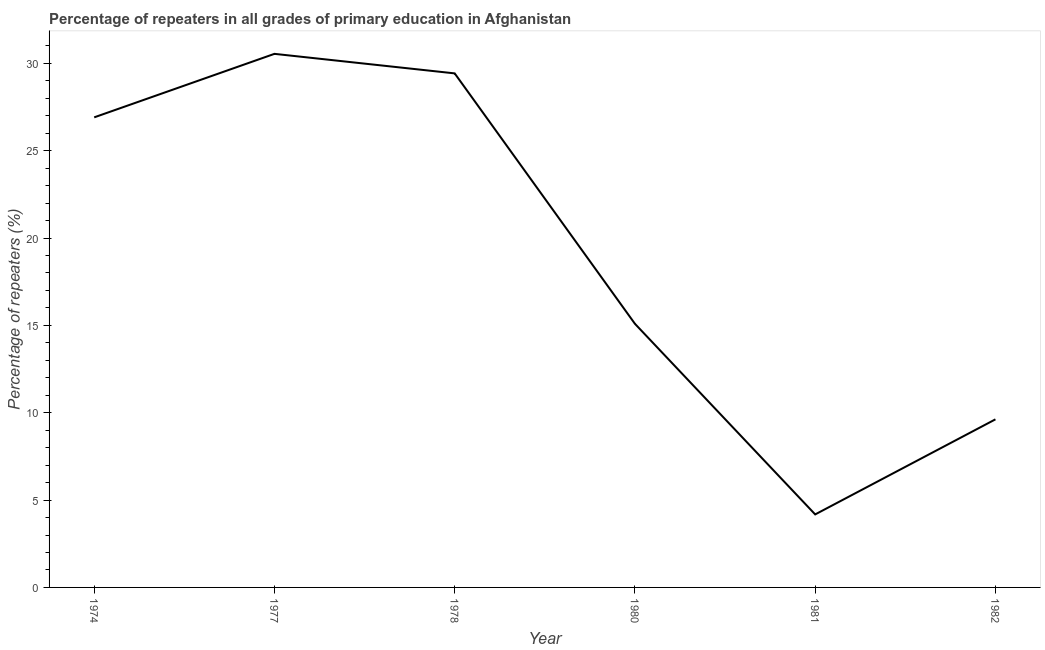What is the percentage of repeaters in primary education in 1978?
Keep it short and to the point. 29.43. Across all years, what is the maximum percentage of repeaters in primary education?
Provide a succinct answer. 30.54. Across all years, what is the minimum percentage of repeaters in primary education?
Your answer should be very brief. 4.18. In which year was the percentage of repeaters in primary education maximum?
Keep it short and to the point. 1977. What is the sum of the percentage of repeaters in primary education?
Your answer should be compact. 115.77. What is the difference between the percentage of repeaters in primary education in 1977 and 1978?
Give a very brief answer. 1.12. What is the average percentage of repeaters in primary education per year?
Provide a succinct answer. 19.3. What is the median percentage of repeaters in primary education?
Keep it short and to the point. 21. In how many years, is the percentage of repeaters in primary education greater than 8 %?
Offer a terse response. 5. Do a majority of the years between 1977 and 1980 (inclusive) have percentage of repeaters in primary education greater than 28 %?
Give a very brief answer. Yes. What is the ratio of the percentage of repeaters in primary education in 1981 to that in 1982?
Provide a succinct answer. 0.43. Is the percentage of repeaters in primary education in 1974 less than that in 1980?
Your response must be concise. No. Is the difference between the percentage of repeaters in primary education in 1978 and 1981 greater than the difference between any two years?
Make the answer very short. No. What is the difference between the highest and the second highest percentage of repeaters in primary education?
Give a very brief answer. 1.12. Is the sum of the percentage of repeaters in primary education in 1974 and 1978 greater than the maximum percentage of repeaters in primary education across all years?
Offer a terse response. Yes. What is the difference between the highest and the lowest percentage of repeaters in primary education?
Provide a succinct answer. 26.36. In how many years, is the percentage of repeaters in primary education greater than the average percentage of repeaters in primary education taken over all years?
Ensure brevity in your answer.  3. Does the percentage of repeaters in primary education monotonically increase over the years?
Keep it short and to the point. No. Are the values on the major ticks of Y-axis written in scientific E-notation?
Your answer should be very brief. No. Does the graph contain any zero values?
Make the answer very short. No. What is the title of the graph?
Your response must be concise. Percentage of repeaters in all grades of primary education in Afghanistan. What is the label or title of the Y-axis?
Offer a terse response. Percentage of repeaters (%). What is the Percentage of repeaters (%) in 1974?
Your answer should be very brief. 26.91. What is the Percentage of repeaters (%) in 1977?
Your answer should be very brief. 30.54. What is the Percentage of repeaters (%) in 1978?
Give a very brief answer. 29.43. What is the Percentage of repeaters (%) in 1980?
Provide a succinct answer. 15.09. What is the Percentage of repeaters (%) of 1981?
Give a very brief answer. 4.18. What is the Percentage of repeaters (%) in 1982?
Offer a terse response. 9.62. What is the difference between the Percentage of repeaters (%) in 1974 and 1977?
Offer a terse response. -3.64. What is the difference between the Percentage of repeaters (%) in 1974 and 1978?
Provide a succinct answer. -2.52. What is the difference between the Percentage of repeaters (%) in 1974 and 1980?
Make the answer very short. 11.82. What is the difference between the Percentage of repeaters (%) in 1974 and 1981?
Offer a very short reply. 22.73. What is the difference between the Percentage of repeaters (%) in 1974 and 1982?
Your response must be concise. 17.29. What is the difference between the Percentage of repeaters (%) in 1977 and 1978?
Offer a terse response. 1.12. What is the difference between the Percentage of repeaters (%) in 1977 and 1980?
Provide a succinct answer. 15.45. What is the difference between the Percentage of repeaters (%) in 1977 and 1981?
Provide a short and direct response. 26.36. What is the difference between the Percentage of repeaters (%) in 1977 and 1982?
Keep it short and to the point. 20.92. What is the difference between the Percentage of repeaters (%) in 1978 and 1980?
Your answer should be very brief. 14.33. What is the difference between the Percentage of repeaters (%) in 1978 and 1981?
Give a very brief answer. 25.25. What is the difference between the Percentage of repeaters (%) in 1978 and 1982?
Your answer should be compact. 19.8. What is the difference between the Percentage of repeaters (%) in 1980 and 1981?
Provide a short and direct response. 10.91. What is the difference between the Percentage of repeaters (%) in 1980 and 1982?
Your answer should be very brief. 5.47. What is the difference between the Percentage of repeaters (%) in 1981 and 1982?
Keep it short and to the point. -5.44. What is the ratio of the Percentage of repeaters (%) in 1974 to that in 1977?
Provide a short and direct response. 0.88. What is the ratio of the Percentage of repeaters (%) in 1974 to that in 1978?
Keep it short and to the point. 0.91. What is the ratio of the Percentage of repeaters (%) in 1974 to that in 1980?
Keep it short and to the point. 1.78. What is the ratio of the Percentage of repeaters (%) in 1974 to that in 1981?
Offer a very short reply. 6.44. What is the ratio of the Percentage of repeaters (%) in 1974 to that in 1982?
Ensure brevity in your answer.  2.8. What is the ratio of the Percentage of repeaters (%) in 1977 to that in 1978?
Offer a terse response. 1.04. What is the ratio of the Percentage of repeaters (%) in 1977 to that in 1980?
Provide a short and direct response. 2.02. What is the ratio of the Percentage of repeaters (%) in 1977 to that in 1981?
Provide a succinct answer. 7.31. What is the ratio of the Percentage of repeaters (%) in 1977 to that in 1982?
Your answer should be very brief. 3.17. What is the ratio of the Percentage of repeaters (%) in 1978 to that in 1980?
Make the answer very short. 1.95. What is the ratio of the Percentage of repeaters (%) in 1978 to that in 1981?
Your answer should be very brief. 7.04. What is the ratio of the Percentage of repeaters (%) in 1978 to that in 1982?
Make the answer very short. 3.06. What is the ratio of the Percentage of repeaters (%) in 1980 to that in 1981?
Provide a succinct answer. 3.61. What is the ratio of the Percentage of repeaters (%) in 1980 to that in 1982?
Your answer should be very brief. 1.57. What is the ratio of the Percentage of repeaters (%) in 1981 to that in 1982?
Give a very brief answer. 0.43. 